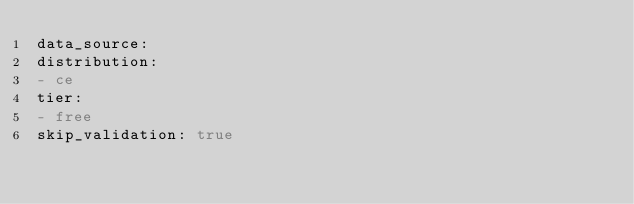<code> <loc_0><loc_0><loc_500><loc_500><_YAML_>data_source:
distribution:
- ce
tier:
- free
skip_validation: true
</code> 